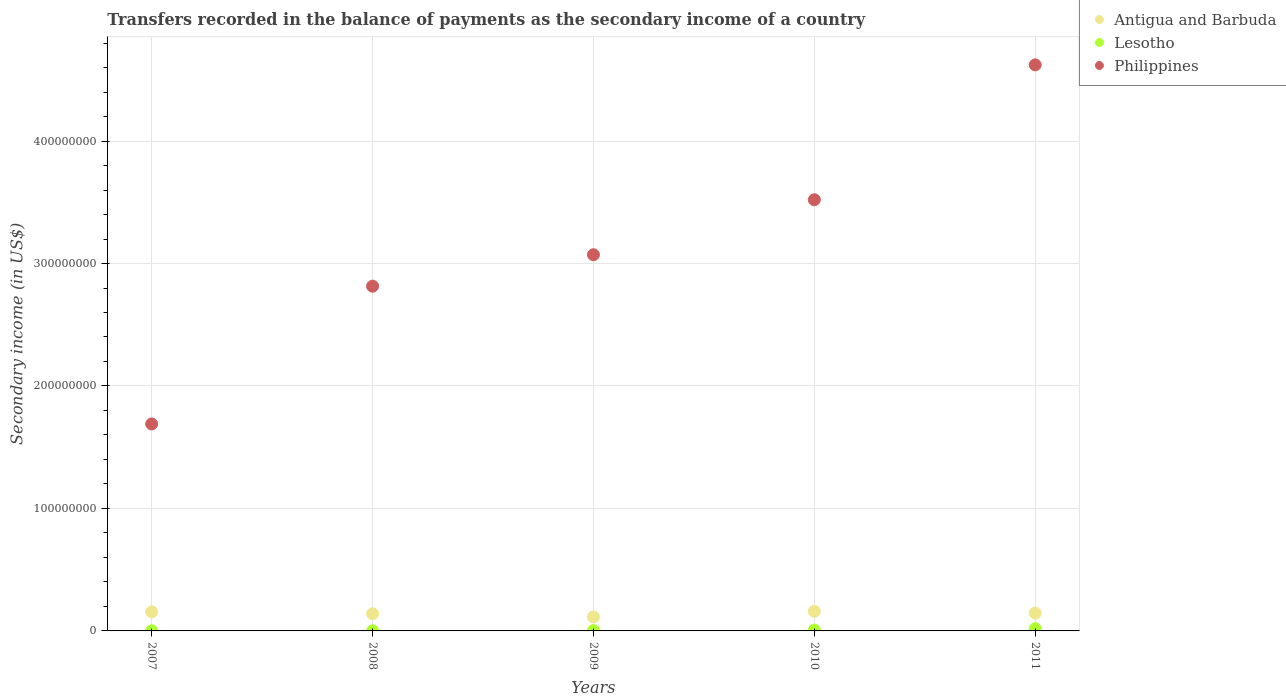What is the secondary income of in Antigua and Barbuda in 2010?
Your answer should be compact. 1.60e+07. Across all years, what is the maximum secondary income of in Philippines?
Your answer should be compact. 4.62e+08. Across all years, what is the minimum secondary income of in Antigua and Barbuda?
Provide a short and direct response. 1.14e+07. In which year was the secondary income of in Philippines maximum?
Provide a short and direct response. 2011. In which year was the secondary income of in Antigua and Barbuda minimum?
Keep it short and to the point. 2009. What is the total secondary income of in Philippines in the graph?
Keep it short and to the point. 1.57e+09. What is the difference between the secondary income of in Lesotho in 2007 and that in 2008?
Provide a succinct answer. 2.74e+04. What is the difference between the secondary income of in Philippines in 2010 and the secondary income of in Antigua and Barbuda in 2009?
Make the answer very short. 3.41e+08. What is the average secondary income of in Lesotho per year?
Offer a very short reply. 5.91e+05. In the year 2008, what is the difference between the secondary income of in Lesotho and secondary income of in Antigua and Barbuda?
Your answer should be very brief. -1.39e+07. What is the ratio of the secondary income of in Antigua and Barbuda in 2009 to that in 2010?
Give a very brief answer. 0.71. What is the difference between the highest and the second highest secondary income of in Lesotho?
Provide a short and direct response. 1.14e+06. What is the difference between the highest and the lowest secondary income of in Philippines?
Ensure brevity in your answer.  2.93e+08. Is it the case that in every year, the sum of the secondary income of in Philippines and secondary income of in Antigua and Barbuda  is greater than the secondary income of in Lesotho?
Your answer should be very brief. Yes. Is the secondary income of in Lesotho strictly greater than the secondary income of in Antigua and Barbuda over the years?
Give a very brief answer. No. Is the secondary income of in Antigua and Barbuda strictly less than the secondary income of in Lesotho over the years?
Your answer should be compact. No. How many dotlines are there?
Provide a succinct answer. 3. How many years are there in the graph?
Your response must be concise. 5. Does the graph contain any zero values?
Offer a terse response. No. Does the graph contain grids?
Make the answer very short. Yes. Where does the legend appear in the graph?
Offer a terse response. Top right. How are the legend labels stacked?
Make the answer very short. Vertical. What is the title of the graph?
Your answer should be compact. Transfers recorded in the balance of payments as the secondary income of a country. What is the label or title of the Y-axis?
Offer a very short reply. Secondary income (in US$). What is the Secondary income (in US$) in Antigua and Barbuda in 2007?
Your response must be concise. 1.56e+07. What is the Secondary income (in US$) of Lesotho in 2007?
Provide a short and direct response. 1.18e+05. What is the Secondary income (in US$) of Philippines in 2007?
Make the answer very short. 1.69e+08. What is the Secondary income (in US$) in Antigua and Barbuda in 2008?
Ensure brevity in your answer.  1.40e+07. What is the Secondary income (in US$) in Lesotho in 2008?
Offer a very short reply. 9.02e+04. What is the Secondary income (in US$) of Philippines in 2008?
Keep it short and to the point. 2.81e+08. What is the Secondary income (in US$) in Antigua and Barbuda in 2009?
Your answer should be compact. 1.14e+07. What is the Secondary income (in US$) in Lesotho in 2009?
Ensure brevity in your answer.  3.02e+05. What is the Secondary income (in US$) in Philippines in 2009?
Your response must be concise. 3.07e+08. What is the Secondary income (in US$) of Antigua and Barbuda in 2010?
Make the answer very short. 1.60e+07. What is the Secondary income (in US$) in Lesotho in 2010?
Offer a terse response. 6.52e+05. What is the Secondary income (in US$) of Philippines in 2010?
Your answer should be very brief. 3.52e+08. What is the Secondary income (in US$) in Antigua and Barbuda in 2011?
Offer a very short reply. 1.45e+07. What is the Secondary income (in US$) in Lesotho in 2011?
Ensure brevity in your answer.  1.79e+06. What is the Secondary income (in US$) of Philippines in 2011?
Ensure brevity in your answer.  4.62e+08. Across all years, what is the maximum Secondary income (in US$) in Antigua and Barbuda?
Provide a succinct answer. 1.60e+07. Across all years, what is the maximum Secondary income (in US$) of Lesotho?
Your answer should be compact. 1.79e+06. Across all years, what is the maximum Secondary income (in US$) in Philippines?
Offer a very short reply. 4.62e+08. Across all years, what is the minimum Secondary income (in US$) in Antigua and Barbuda?
Provide a short and direct response. 1.14e+07. Across all years, what is the minimum Secondary income (in US$) in Lesotho?
Your answer should be very brief. 9.02e+04. Across all years, what is the minimum Secondary income (in US$) in Philippines?
Keep it short and to the point. 1.69e+08. What is the total Secondary income (in US$) in Antigua and Barbuda in the graph?
Make the answer very short. 7.16e+07. What is the total Secondary income (in US$) in Lesotho in the graph?
Provide a short and direct response. 2.95e+06. What is the total Secondary income (in US$) of Philippines in the graph?
Give a very brief answer. 1.57e+09. What is the difference between the Secondary income (in US$) in Antigua and Barbuda in 2007 and that in 2008?
Your answer should be compact. 1.57e+06. What is the difference between the Secondary income (in US$) in Lesotho in 2007 and that in 2008?
Provide a short and direct response. 2.74e+04. What is the difference between the Secondary income (in US$) in Philippines in 2007 and that in 2008?
Ensure brevity in your answer.  -1.12e+08. What is the difference between the Secondary income (in US$) in Antigua and Barbuda in 2007 and that in 2009?
Keep it short and to the point. 4.15e+06. What is the difference between the Secondary income (in US$) of Lesotho in 2007 and that in 2009?
Give a very brief answer. -1.84e+05. What is the difference between the Secondary income (in US$) of Philippines in 2007 and that in 2009?
Provide a succinct answer. -1.38e+08. What is the difference between the Secondary income (in US$) of Antigua and Barbuda in 2007 and that in 2010?
Ensure brevity in your answer.  -4.28e+05. What is the difference between the Secondary income (in US$) of Lesotho in 2007 and that in 2010?
Provide a succinct answer. -5.34e+05. What is the difference between the Secondary income (in US$) of Philippines in 2007 and that in 2010?
Your answer should be very brief. -1.83e+08. What is the difference between the Secondary income (in US$) in Antigua and Barbuda in 2007 and that in 2011?
Offer a terse response. 1.08e+06. What is the difference between the Secondary income (in US$) in Lesotho in 2007 and that in 2011?
Your response must be concise. -1.68e+06. What is the difference between the Secondary income (in US$) in Philippines in 2007 and that in 2011?
Make the answer very short. -2.93e+08. What is the difference between the Secondary income (in US$) of Antigua and Barbuda in 2008 and that in 2009?
Offer a very short reply. 2.59e+06. What is the difference between the Secondary income (in US$) of Lesotho in 2008 and that in 2009?
Your answer should be compact. -2.11e+05. What is the difference between the Secondary income (in US$) in Philippines in 2008 and that in 2009?
Give a very brief answer. -2.57e+07. What is the difference between the Secondary income (in US$) in Antigua and Barbuda in 2008 and that in 2010?
Offer a terse response. -2.00e+06. What is the difference between the Secondary income (in US$) of Lesotho in 2008 and that in 2010?
Your answer should be compact. -5.62e+05. What is the difference between the Secondary income (in US$) of Philippines in 2008 and that in 2010?
Provide a succinct answer. -7.06e+07. What is the difference between the Secondary income (in US$) in Antigua and Barbuda in 2008 and that in 2011?
Make the answer very short. -4.83e+05. What is the difference between the Secondary income (in US$) in Lesotho in 2008 and that in 2011?
Give a very brief answer. -1.70e+06. What is the difference between the Secondary income (in US$) of Philippines in 2008 and that in 2011?
Provide a succinct answer. -1.81e+08. What is the difference between the Secondary income (in US$) of Antigua and Barbuda in 2009 and that in 2010?
Your answer should be compact. -4.58e+06. What is the difference between the Secondary income (in US$) in Lesotho in 2009 and that in 2010?
Ensure brevity in your answer.  -3.50e+05. What is the difference between the Secondary income (in US$) in Philippines in 2009 and that in 2010?
Ensure brevity in your answer.  -4.49e+07. What is the difference between the Secondary income (in US$) in Antigua and Barbuda in 2009 and that in 2011?
Offer a very short reply. -3.07e+06. What is the difference between the Secondary income (in US$) in Lesotho in 2009 and that in 2011?
Your answer should be very brief. -1.49e+06. What is the difference between the Secondary income (in US$) of Philippines in 2009 and that in 2011?
Ensure brevity in your answer.  -1.55e+08. What is the difference between the Secondary income (in US$) of Antigua and Barbuda in 2010 and that in 2011?
Your answer should be compact. 1.51e+06. What is the difference between the Secondary income (in US$) in Lesotho in 2010 and that in 2011?
Offer a terse response. -1.14e+06. What is the difference between the Secondary income (in US$) in Philippines in 2010 and that in 2011?
Your answer should be compact. -1.10e+08. What is the difference between the Secondary income (in US$) in Antigua and Barbuda in 2007 and the Secondary income (in US$) in Lesotho in 2008?
Your answer should be compact. 1.55e+07. What is the difference between the Secondary income (in US$) of Antigua and Barbuda in 2007 and the Secondary income (in US$) of Philippines in 2008?
Keep it short and to the point. -2.66e+08. What is the difference between the Secondary income (in US$) of Lesotho in 2007 and the Secondary income (in US$) of Philippines in 2008?
Offer a very short reply. -2.81e+08. What is the difference between the Secondary income (in US$) in Antigua and Barbuda in 2007 and the Secondary income (in US$) in Lesotho in 2009?
Offer a very short reply. 1.53e+07. What is the difference between the Secondary income (in US$) of Antigua and Barbuda in 2007 and the Secondary income (in US$) of Philippines in 2009?
Your answer should be compact. -2.92e+08. What is the difference between the Secondary income (in US$) of Lesotho in 2007 and the Secondary income (in US$) of Philippines in 2009?
Keep it short and to the point. -3.07e+08. What is the difference between the Secondary income (in US$) of Antigua and Barbuda in 2007 and the Secondary income (in US$) of Lesotho in 2010?
Give a very brief answer. 1.49e+07. What is the difference between the Secondary income (in US$) of Antigua and Barbuda in 2007 and the Secondary income (in US$) of Philippines in 2010?
Offer a very short reply. -3.36e+08. What is the difference between the Secondary income (in US$) in Lesotho in 2007 and the Secondary income (in US$) in Philippines in 2010?
Provide a succinct answer. -3.52e+08. What is the difference between the Secondary income (in US$) of Antigua and Barbuda in 2007 and the Secondary income (in US$) of Lesotho in 2011?
Offer a very short reply. 1.38e+07. What is the difference between the Secondary income (in US$) in Antigua and Barbuda in 2007 and the Secondary income (in US$) in Philippines in 2011?
Your answer should be very brief. -4.47e+08. What is the difference between the Secondary income (in US$) in Lesotho in 2007 and the Secondary income (in US$) in Philippines in 2011?
Give a very brief answer. -4.62e+08. What is the difference between the Secondary income (in US$) of Antigua and Barbuda in 2008 and the Secondary income (in US$) of Lesotho in 2009?
Offer a terse response. 1.37e+07. What is the difference between the Secondary income (in US$) in Antigua and Barbuda in 2008 and the Secondary income (in US$) in Philippines in 2009?
Offer a terse response. -2.93e+08. What is the difference between the Secondary income (in US$) of Lesotho in 2008 and the Secondary income (in US$) of Philippines in 2009?
Offer a very short reply. -3.07e+08. What is the difference between the Secondary income (in US$) of Antigua and Barbuda in 2008 and the Secondary income (in US$) of Lesotho in 2010?
Make the answer very short. 1.34e+07. What is the difference between the Secondary income (in US$) of Antigua and Barbuda in 2008 and the Secondary income (in US$) of Philippines in 2010?
Your answer should be compact. -3.38e+08. What is the difference between the Secondary income (in US$) in Lesotho in 2008 and the Secondary income (in US$) in Philippines in 2010?
Your answer should be compact. -3.52e+08. What is the difference between the Secondary income (in US$) of Antigua and Barbuda in 2008 and the Secondary income (in US$) of Lesotho in 2011?
Your answer should be very brief. 1.22e+07. What is the difference between the Secondary income (in US$) of Antigua and Barbuda in 2008 and the Secondary income (in US$) of Philippines in 2011?
Offer a very short reply. -4.48e+08. What is the difference between the Secondary income (in US$) of Lesotho in 2008 and the Secondary income (in US$) of Philippines in 2011?
Your response must be concise. -4.62e+08. What is the difference between the Secondary income (in US$) of Antigua and Barbuda in 2009 and the Secondary income (in US$) of Lesotho in 2010?
Make the answer very short. 1.08e+07. What is the difference between the Secondary income (in US$) of Antigua and Barbuda in 2009 and the Secondary income (in US$) of Philippines in 2010?
Offer a terse response. -3.41e+08. What is the difference between the Secondary income (in US$) in Lesotho in 2009 and the Secondary income (in US$) in Philippines in 2010?
Ensure brevity in your answer.  -3.52e+08. What is the difference between the Secondary income (in US$) of Antigua and Barbuda in 2009 and the Secondary income (in US$) of Lesotho in 2011?
Make the answer very short. 9.65e+06. What is the difference between the Secondary income (in US$) in Antigua and Barbuda in 2009 and the Secondary income (in US$) in Philippines in 2011?
Ensure brevity in your answer.  -4.51e+08. What is the difference between the Secondary income (in US$) of Lesotho in 2009 and the Secondary income (in US$) of Philippines in 2011?
Ensure brevity in your answer.  -4.62e+08. What is the difference between the Secondary income (in US$) of Antigua and Barbuda in 2010 and the Secondary income (in US$) of Lesotho in 2011?
Keep it short and to the point. 1.42e+07. What is the difference between the Secondary income (in US$) of Antigua and Barbuda in 2010 and the Secondary income (in US$) of Philippines in 2011?
Give a very brief answer. -4.46e+08. What is the difference between the Secondary income (in US$) of Lesotho in 2010 and the Secondary income (in US$) of Philippines in 2011?
Provide a short and direct response. -4.62e+08. What is the average Secondary income (in US$) of Antigua and Barbuda per year?
Your answer should be compact. 1.43e+07. What is the average Secondary income (in US$) in Lesotho per year?
Your answer should be very brief. 5.91e+05. What is the average Secondary income (in US$) in Philippines per year?
Your answer should be compact. 3.14e+08. In the year 2007, what is the difference between the Secondary income (in US$) in Antigua and Barbuda and Secondary income (in US$) in Lesotho?
Your response must be concise. 1.55e+07. In the year 2007, what is the difference between the Secondary income (in US$) of Antigua and Barbuda and Secondary income (in US$) of Philippines?
Offer a terse response. -1.53e+08. In the year 2007, what is the difference between the Secondary income (in US$) in Lesotho and Secondary income (in US$) in Philippines?
Provide a short and direct response. -1.69e+08. In the year 2008, what is the difference between the Secondary income (in US$) of Antigua and Barbuda and Secondary income (in US$) of Lesotho?
Make the answer very short. 1.39e+07. In the year 2008, what is the difference between the Secondary income (in US$) of Antigua and Barbuda and Secondary income (in US$) of Philippines?
Ensure brevity in your answer.  -2.67e+08. In the year 2008, what is the difference between the Secondary income (in US$) in Lesotho and Secondary income (in US$) in Philippines?
Give a very brief answer. -2.81e+08. In the year 2009, what is the difference between the Secondary income (in US$) of Antigua and Barbuda and Secondary income (in US$) of Lesotho?
Give a very brief answer. 1.11e+07. In the year 2009, what is the difference between the Secondary income (in US$) in Antigua and Barbuda and Secondary income (in US$) in Philippines?
Provide a short and direct response. -2.96e+08. In the year 2009, what is the difference between the Secondary income (in US$) of Lesotho and Secondary income (in US$) of Philippines?
Offer a very short reply. -3.07e+08. In the year 2010, what is the difference between the Secondary income (in US$) of Antigua and Barbuda and Secondary income (in US$) of Lesotho?
Offer a terse response. 1.54e+07. In the year 2010, what is the difference between the Secondary income (in US$) of Antigua and Barbuda and Secondary income (in US$) of Philippines?
Your answer should be very brief. -3.36e+08. In the year 2010, what is the difference between the Secondary income (in US$) of Lesotho and Secondary income (in US$) of Philippines?
Your response must be concise. -3.51e+08. In the year 2011, what is the difference between the Secondary income (in US$) in Antigua and Barbuda and Secondary income (in US$) in Lesotho?
Give a very brief answer. 1.27e+07. In the year 2011, what is the difference between the Secondary income (in US$) in Antigua and Barbuda and Secondary income (in US$) in Philippines?
Offer a very short reply. -4.48e+08. In the year 2011, what is the difference between the Secondary income (in US$) in Lesotho and Secondary income (in US$) in Philippines?
Ensure brevity in your answer.  -4.60e+08. What is the ratio of the Secondary income (in US$) in Antigua and Barbuda in 2007 to that in 2008?
Offer a terse response. 1.11. What is the ratio of the Secondary income (in US$) in Lesotho in 2007 to that in 2008?
Give a very brief answer. 1.3. What is the ratio of the Secondary income (in US$) of Philippines in 2007 to that in 2008?
Offer a very short reply. 0.6. What is the ratio of the Secondary income (in US$) in Antigua and Barbuda in 2007 to that in 2009?
Provide a succinct answer. 1.36. What is the ratio of the Secondary income (in US$) in Lesotho in 2007 to that in 2009?
Give a very brief answer. 0.39. What is the ratio of the Secondary income (in US$) in Philippines in 2007 to that in 2009?
Provide a succinct answer. 0.55. What is the ratio of the Secondary income (in US$) in Antigua and Barbuda in 2007 to that in 2010?
Ensure brevity in your answer.  0.97. What is the ratio of the Secondary income (in US$) of Lesotho in 2007 to that in 2010?
Give a very brief answer. 0.18. What is the ratio of the Secondary income (in US$) in Philippines in 2007 to that in 2010?
Give a very brief answer. 0.48. What is the ratio of the Secondary income (in US$) of Antigua and Barbuda in 2007 to that in 2011?
Your answer should be compact. 1.07. What is the ratio of the Secondary income (in US$) of Lesotho in 2007 to that in 2011?
Keep it short and to the point. 0.07. What is the ratio of the Secondary income (in US$) of Philippines in 2007 to that in 2011?
Offer a terse response. 0.37. What is the ratio of the Secondary income (in US$) in Antigua and Barbuda in 2008 to that in 2009?
Your response must be concise. 1.23. What is the ratio of the Secondary income (in US$) in Lesotho in 2008 to that in 2009?
Keep it short and to the point. 0.3. What is the ratio of the Secondary income (in US$) of Philippines in 2008 to that in 2009?
Offer a very short reply. 0.92. What is the ratio of the Secondary income (in US$) in Antigua and Barbuda in 2008 to that in 2010?
Your answer should be very brief. 0.88. What is the ratio of the Secondary income (in US$) of Lesotho in 2008 to that in 2010?
Make the answer very short. 0.14. What is the ratio of the Secondary income (in US$) in Philippines in 2008 to that in 2010?
Ensure brevity in your answer.  0.8. What is the ratio of the Secondary income (in US$) of Antigua and Barbuda in 2008 to that in 2011?
Your answer should be compact. 0.97. What is the ratio of the Secondary income (in US$) of Lesotho in 2008 to that in 2011?
Provide a short and direct response. 0.05. What is the ratio of the Secondary income (in US$) in Philippines in 2008 to that in 2011?
Your answer should be compact. 0.61. What is the ratio of the Secondary income (in US$) of Antigua and Barbuda in 2009 to that in 2010?
Provide a short and direct response. 0.71. What is the ratio of the Secondary income (in US$) in Lesotho in 2009 to that in 2010?
Your response must be concise. 0.46. What is the ratio of the Secondary income (in US$) in Philippines in 2009 to that in 2010?
Provide a succinct answer. 0.87. What is the ratio of the Secondary income (in US$) in Antigua and Barbuda in 2009 to that in 2011?
Give a very brief answer. 0.79. What is the ratio of the Secondary income (in US$) in Lesotho in 2009 to that in 2011?
Give a very brief answer. 0.17. What is the ratio of the Secondary income (in US$) of Philippines in 2009 to that in 2011?
Your answer should be very brief. 0.66. What is the ratio of the Secondary income (in US$) of Antigua and Barbuda in 2010 to that in 2011?
Provide a succinct answer. 1.1. What is the ratio of the Secondary income (in US$) in Lesotho in 2010 to that in 2011?
Provide a short and direct response. 0.36. What is the ratio of the Secondary income (in US$) of Philippines in 2010 to that in 2011?
Make the answer very short. 0.76. What is the difference between the highest and the second highest Secondary income (in US$) of Antigua and Barbuda?
Provide a succinct answer. 4.28e+05. What is the difference between the highest and the second highest Secondary income (in US$) in Lesotho?
Provide a succinct answer. 1.14e+06. What is the difference between the highest and the second highest Secondary income (in US$) in Philippines?
Give a very brief answer. 1.10e+08. What is the difference between the highest and the lowest Secondary income (in US$) in Antigua and Barbuda?
Offer a very short reply. 4.58e+06. What is the difference between the highest and the lowest Secondary income (in US$) in Lesotho?
Keep it short and to the point. 1.70e+06. What is the difference between the highest and the lowest Secondary income (in US$) of Philippines?
Provide a short and direct response. 2.93e+08. 